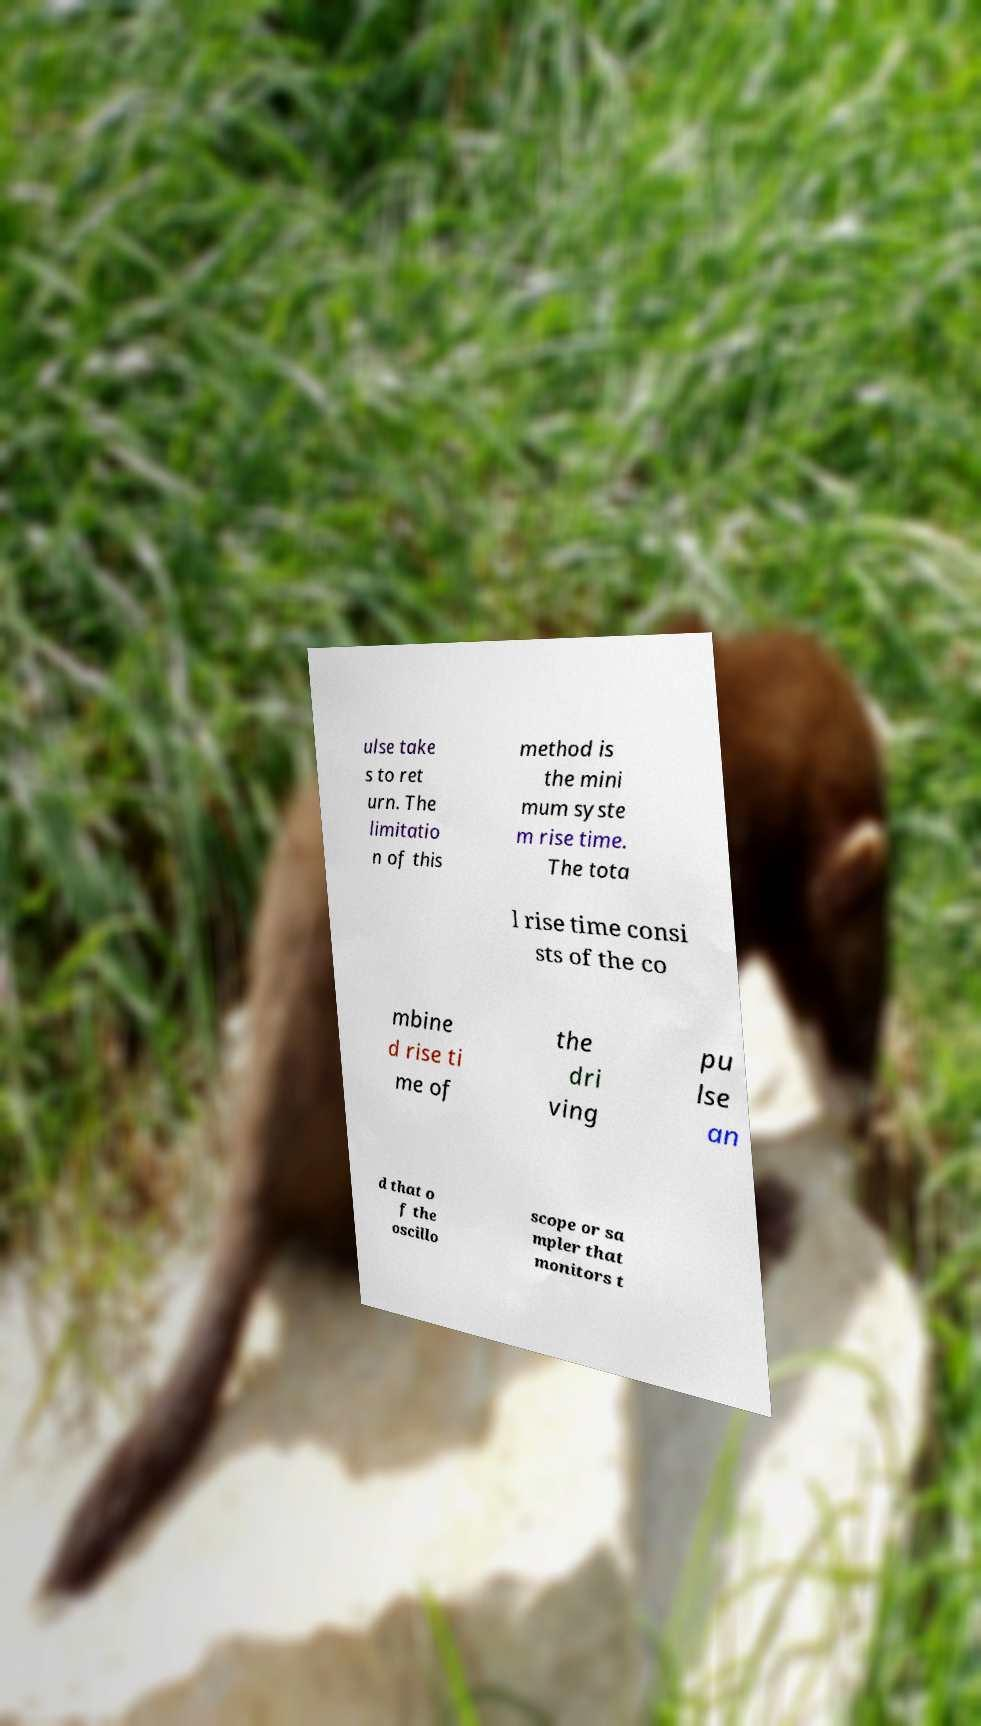What messages or text are displayed in this image? I need them in a readable, typed format. ulse take s to ret urn. The limitatio n of this method is the mini mum syste m rise time. The tota l rise time consi sts of the co mbine d rise ti me of the dri ving pu lse an d that o f the oscillo scope or sa mpler that monitors t 